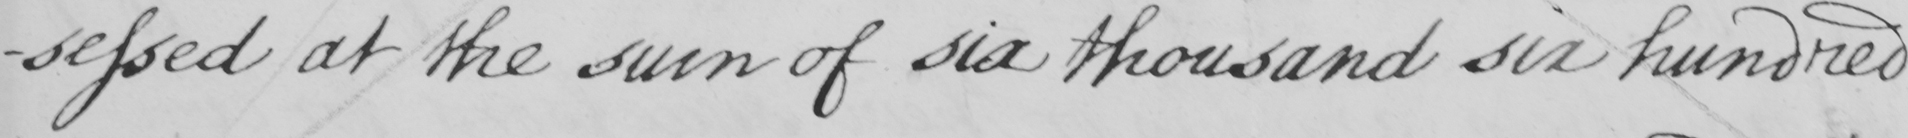Can you tell me what this handwritten text says? -sessed at the sum of six thousand six hundred 